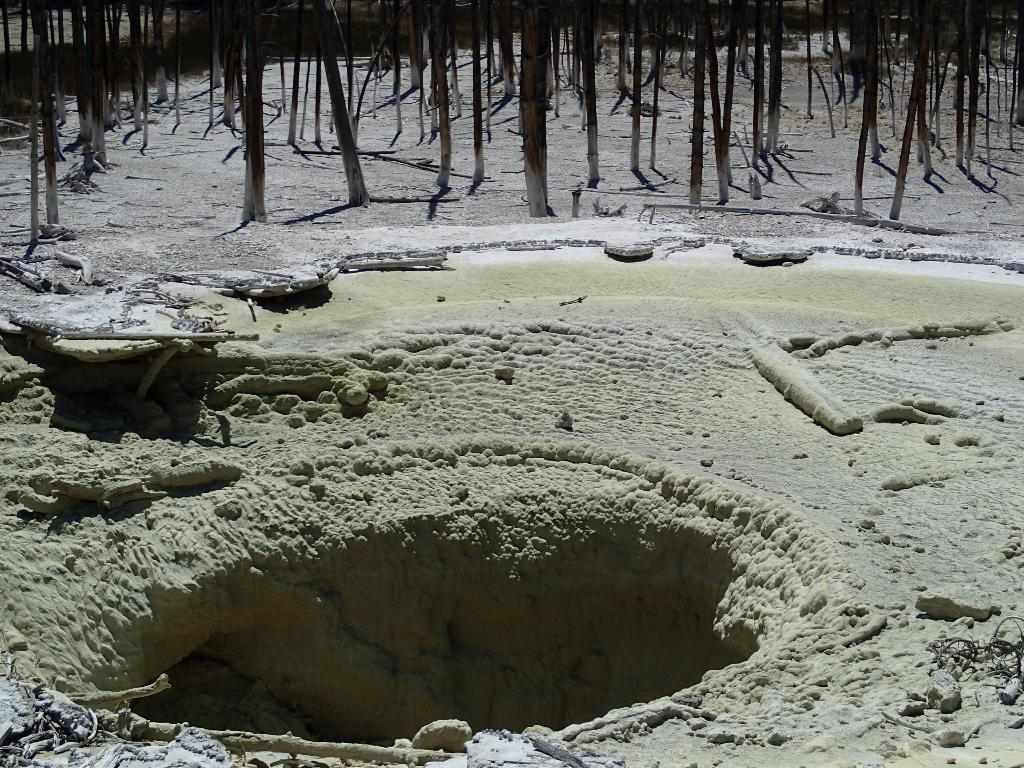What type of vegetation can be seen in the image? There are trees in the image. Can you describe the landscape in the image? There is a hole in front of the trees. What type of engine is powering the jellyfish in the image? There are no jellyfish present in the image, so it is not possible to determine what type of engine might be powering them. 